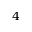<formula> <loc_0><loc_0><loc_500><loc_500>4</formula> 